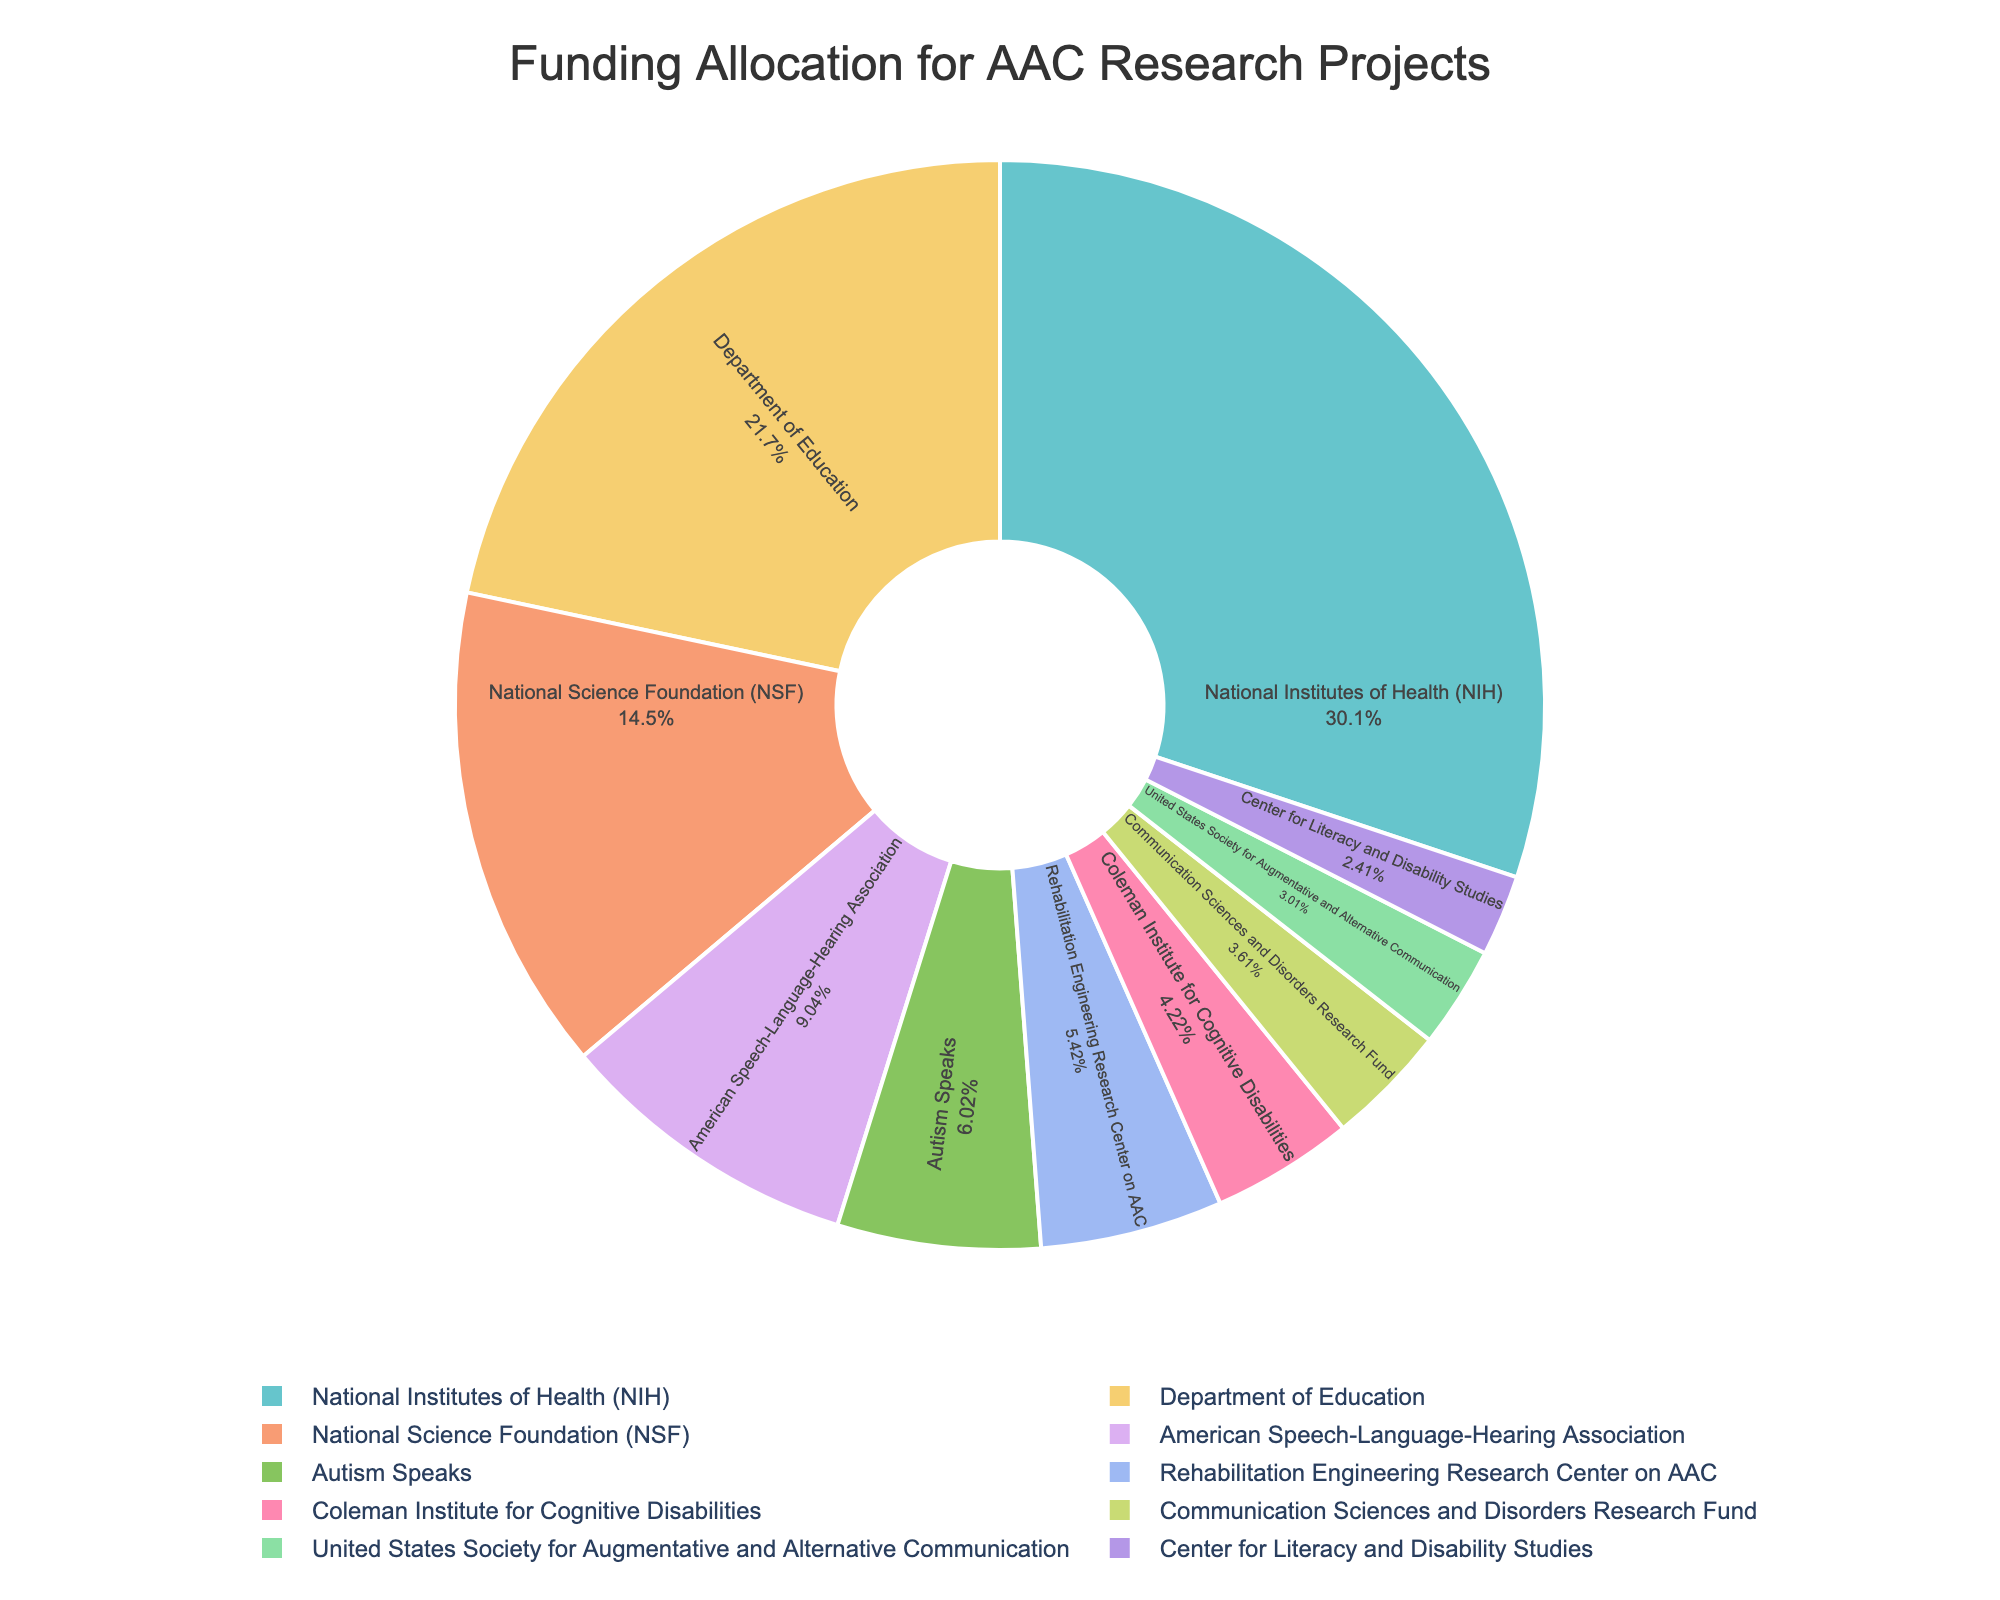Which funding source has the highest allocation? By looking at the sizes of the slices, the slice representing the National Institutes of Health (NIH) is the largest, indicating the highest funding allocation.
Answer: National Institutes of Health (NIH) Which funding source has the smallest allocation? By observing the smallest slice in the pie chart, the slice for the Center for Literacy and Disability Studies is the smallest, indicating the least funding.
Answer: Center for Literacy and Disability Studies What is the total funding received from the National Institutes of Health (NIH) and the Department of Education? The chart shows two slices representing the NIH and the Department of Education. Add the amounts, which are 2,500,000 and 1,800,000 USD, respectively: 2,500,000 + 1,800,000 = 4,300,000 USD.
Answer: 4,300,000 USD How much more funding does the National Science Foundation (NSF) receive compared to Autism Speaks? Identify the slices for NSF and Autism Speaks. NSF receives 1,200,000 USD, and Autism Speaks receives 500,000 USD. Subtract the latter from the former: 1,200,000 - 500,000 = 700,000 USD.
Answer: 700,000 USD Which two funding sources have the most similar allocation amounts? By comparing the sizes of the slices, the slices for the Rehabilitation Engineering Research Center on AAC and the Coleman Institute for Cognitive Disabilities appear most similar. They are 450,000 USD and 350,000 USD, respectively.
Answer: Rehabilitation Engineering Research Center on AAC and Coleman Institute for Cognitive Disabilities Rank the top three funding sources in descending order of their allocation amounts. By identifying the three largest slices, the top three funding sources are: 1) National Institutes of Health (NIH) with 2,500,000 USD, 2) Department of Education with 1,800,000 USD, 3) National Science Foundation (NSF) with 1,200,000 USD.
Answer: NIH, Department of Education, NSF If you combine the funding from the American Speech-Language-Hearing Association, Autism Speaks, and the Communication Sciences and Disorders Research Fund, what percentage of the total funding do they constitute? Sum the amounts: 750,000 + 500,000 + 300,000 = 1,550,000 USD. Calculate the total funding: 2500000 + 1800000 + 1200000 + 750000 + 500000 + 450000 + 350000 + 300000 + 250000 + 200000 = 8,500,000 USD. Percentage = (1,550,000 / 8,500,000) * 100 = 18.24%.
Answer: 18.24% How does the combined funding from the Coleman Institute for Cognitive Disabilities and the Center for Literacy and Disability Studies compare to the funding from the National Science Foundation (NSF)? Sum the amounts: 350,000 + 200,000 = 550,000 USD. Compare to NSF's funding of 1,200,000 USD. NSF receives more: 1,200,000 - 550,000 = 650,000 USD more.
Answer: NSF receives 650,000 USD more What proportion of total funding is allocated to the United States Society for Augmentative and Alternative Communication? The funding amount for this source is 250,000 USD. To find the proportion: (250,000 / 8,500,000) * 100 = 2.94%.
Answer: 2.94% What is the average funding amount among all the sources? Calculate the total funding: 8,500,000 USD. Divide by the number of sources (10). Average = 8,500,000 / 10 = 850,000 USD.
Answer: 850,000 USD 